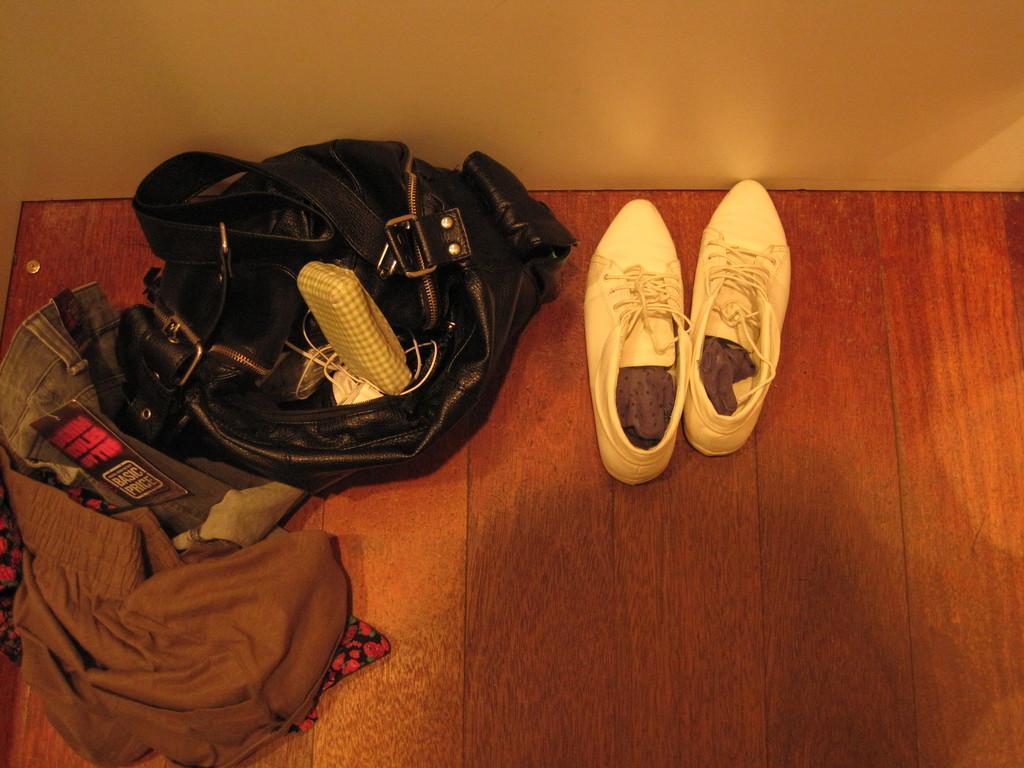In one or two sentences, can you explain what this image depicts? In this image, we can see the wooden surface with some objects like footwear, clothes, a bag with some objects. We can also see the wall. 